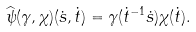<formula> <loc_0><loc_0><loc_500><loc_500>\widehat { \psi } ( \gamma , \chi ) ( \dot { s } , \dot { t } ) = \gamma ( \dot { t } ^ { - 1 } \dot { s } ) \chi ( \dot { t } ) .</formula> 